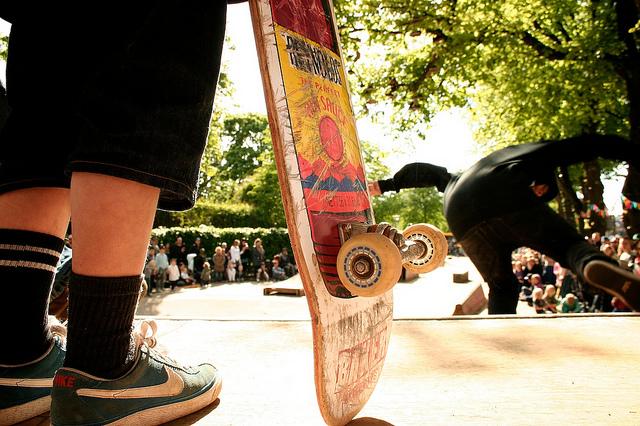How many skateboards are there?
Be succinct. 1. What is written on the bottom of the skateboard?
Give a very brief answer. Baker. Are there a lot of people at the skate park?
Write a very short answer. Yes. 